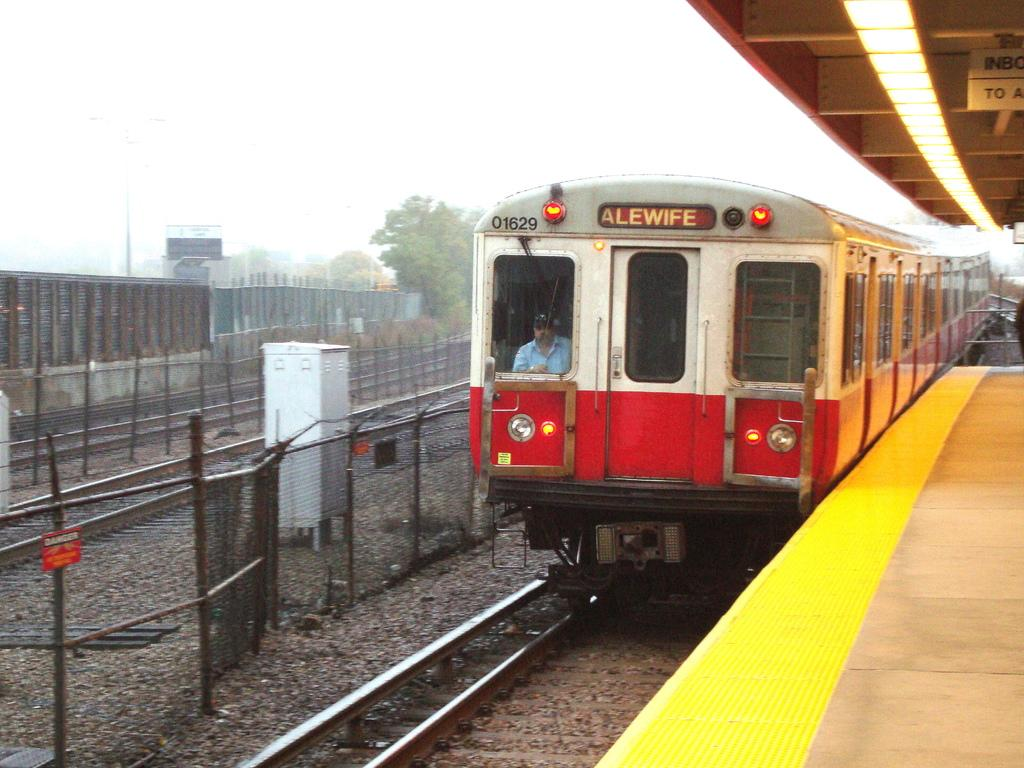<image>
Describe the image concisely. A train that is titled Alewife assumingly where it is headed. 